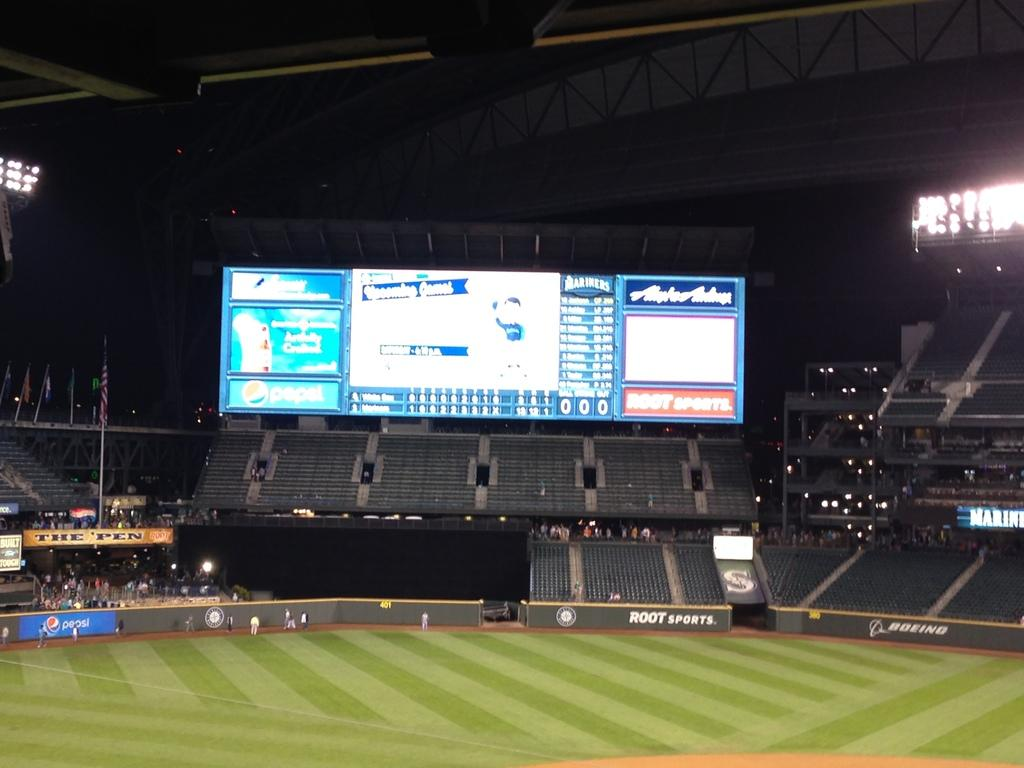<image>
Share a concise interpretation of the image provided. A large electronic scoreboard inside a stdium with a banner for Root Sports. 